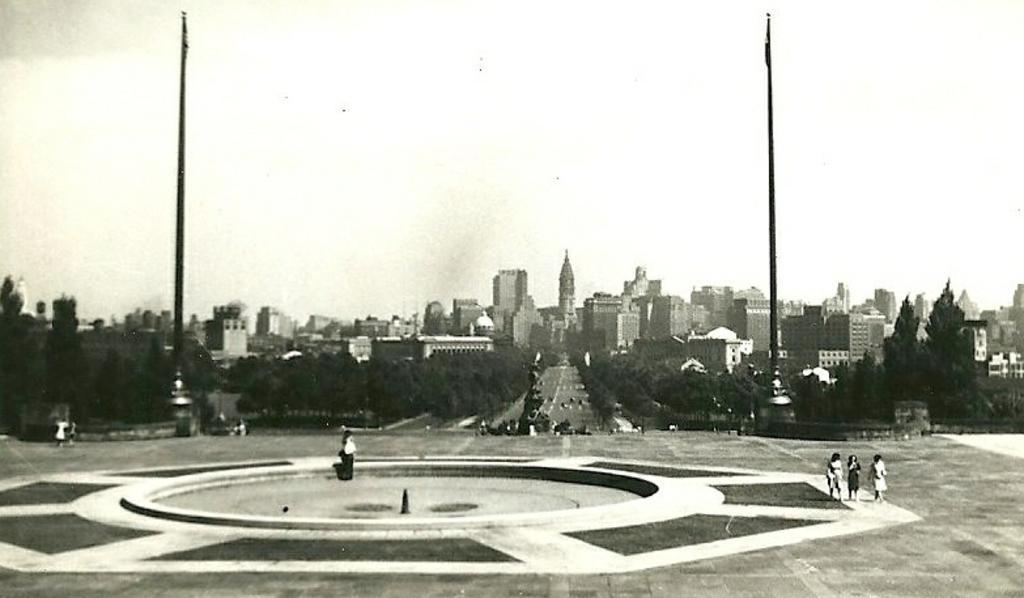Can you describe this image briefly? In the image in the center, we can see a few people are standing. And we can see poles. In the background, we can see the sky, clouds, trees, buildings and vehicles on the road. 